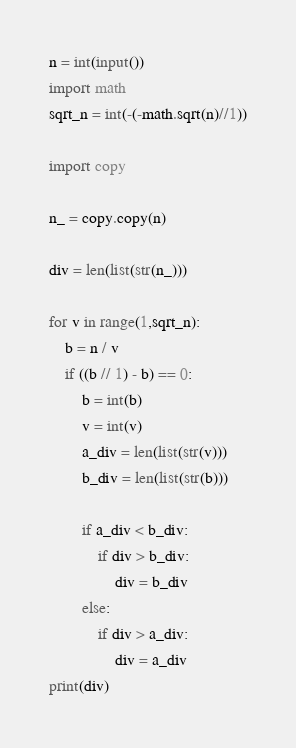<code> <loc_0><loc_0><loc_500><loc_500><_Python_>n = int(input())
import math
sqrt_n = int(-(-math.sqrt(n)//1))

import copy

n_ = copy.copy(n)

div = len(list(str(n_)))

for v in range(1,sqrt_n):
    b = n / v
    if ((b // 1) - b) == 0:
        b = int(b)
        v = int(v)
        a_div = len(list(str(v)))
        b_div = len(list(str(b)))
    
        if a_div < b_div:
            if div > b_div:
                div = b_div
        else:
            if div > a_div:
                div = a_div
print(div)    </code> 